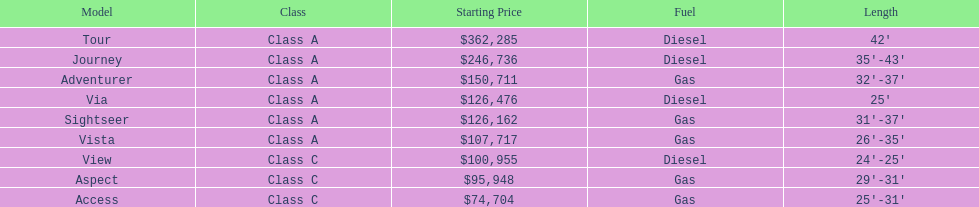Which model is at the top of the list with the highest starting price? Tour. 